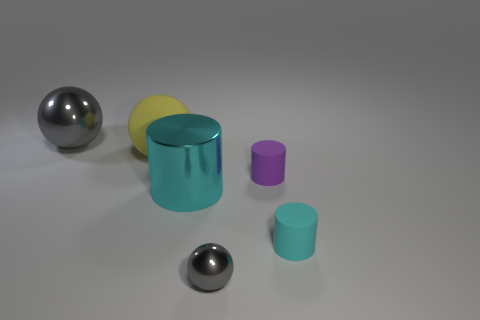Add 3 small blue matte things. How many objects exist? 9 Add 4 purple things. How many purple things are left? 5 Add 1 large yellow metal things. How many large yellow metal things exist? 1 Subtract 0 gray cylinders. How many objects are left? 6 Subtract all tiny cyan rubber cylinders. Subtract all large yellow matte things. How many objects are left? 4 